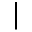<formula> <loc_0><loc_0><loc_500><loc_500>|</formula> 